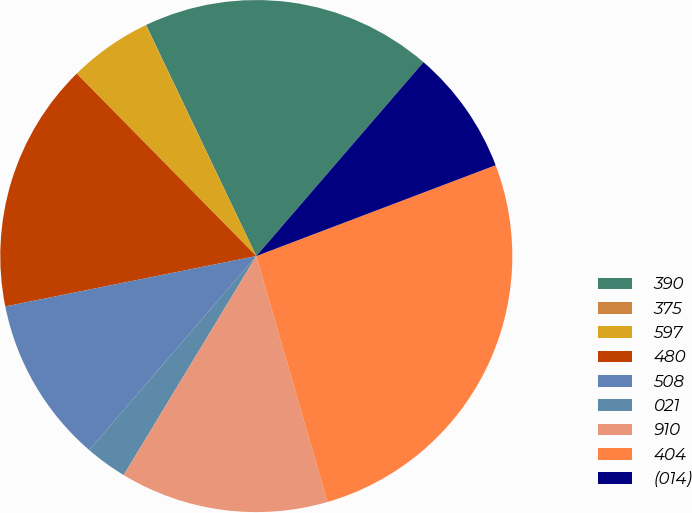Convert chart to OTSL. <chart><loc_0><loc_0><loc_500><loc_500><pie_chart><fcel>390<fcel>375<fcel>597<fcel>480<fcel>508<fcel>021<fcel>910<fcel>404<fcel>(014)<nl><fcel>18.41%<fcel>0.02%<fcel>5.27%<fcel>15.78%<fcel>10.53%<fcel>2.65%<fcel>13.15%<fcel>26.29%<fcel>7.9%<nl></chart> 